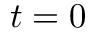<formula> <loc_0><loc_0><loc_500><loc_500>t = 0</formula> 